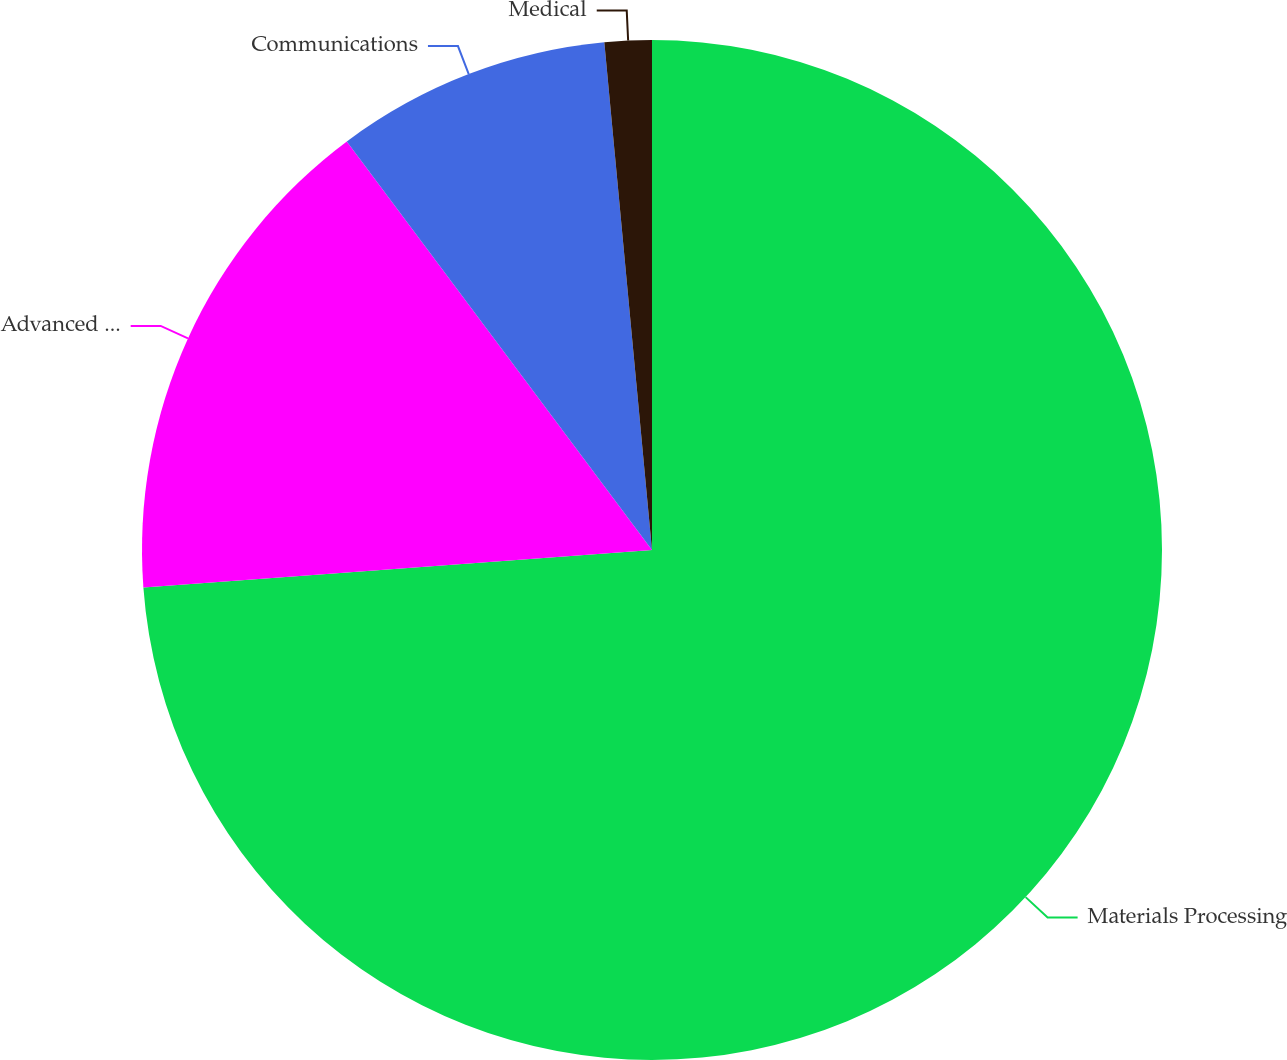Convert chart. <chart><loc_0><loc_0><loc_500><loc_500><pie_chart><fcel>Materials Processing<fcel>Advanced Applications<fcel>Communications<fcel>Medical<nl><fcel>73.83%<fcel>15.96%<fcel>8.72%<fcel>1.49%<nl></chart> 